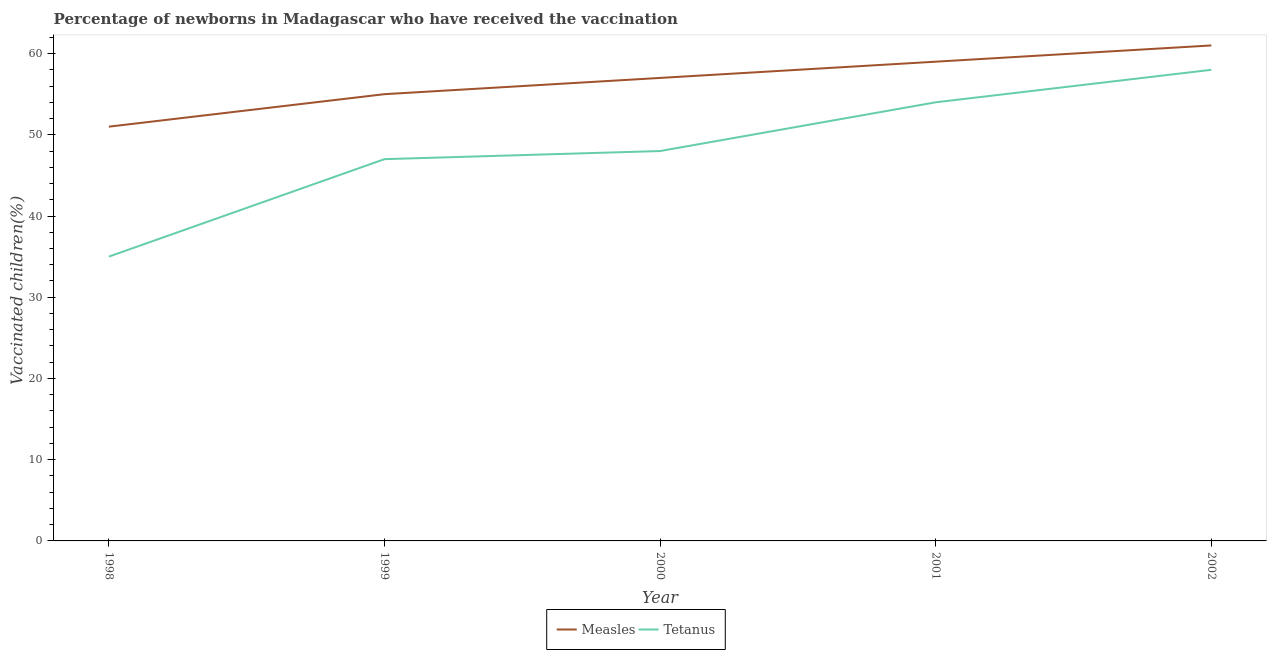Is the number of lines equal to the number of legend labels?
Your answer should be very brief. Yes. What is the percentage of newborns who received vaccination for tetanus in 2001?
Make the answer very short. 54. Across all years, what is the maximum percentage of newborns who received vaccination for tetanus?
Give a very brief answer. 58. Across all years, what is the minimum percentage of newborns who received vaccination for tetanus?
Provide a short and direct response. 35. In which year was the percentage of newborns who received vaccination for measles maximum?
Your response must be concise. 2002. What is the total percentage of newborns who received vaccination for measles in the graph?
Provide a short and direct response. 283. What is the difference between the percentage of newborns who received vaccination for tetanus in 1999 and that in 2000?
Keep it short and to the point. -1. What is the difference between the percentage of newborns who received vaccination for measles in 2001 and the percentage of newborns who received vaccination for tetanus in 1999?
Your response must be concise. 12. What is the average percentage of newborns who received vaccination for tetanus per year?
Provide a short and direct response. 48.4. In the year 2000, what is the difference between the percentage of newborns who received vaccination for tetanus and percentage of newborns who received vaccination for measles?
Give a very brief answer. -9. What is the ratio of the percentage of newborns who received vaccination for tetanus in 1999 to that in 2000?
Your answer should be very brief. 0.98. Is the percentage of newborns who received vaccination for tetanus in 1999 less than that in 2001?
Your answer should be very brief. Yes. Is the difference between the percentage of newborns who received vaccination for measles in 1999 and 2001 greater than the difference between the percentage of newborns who received vaccination for tetanus in 1999 and 2001?
Provide a short and direct response. Yes. What is the difference between the highest and the second highest percentage of newborns who received vaccination for measles?
Your response must be concise. 2. What is the difference between the highest and the lowest percentage of newborns who received vaccination for measles?
Keep it short and to the point. 10. In how many years, is the percentage of newborns who received vaccination for measles greater than the average percentage of newborns who received vaccination for measles taken over all years?
Provide a short and direct response. 3. Does the percentage of newborns who received vaccination for tetanus monotonically increase over the years?
Give a very brief answer. Yes. Is the percentage of newborns who received vaccination for measles strictly greater than the percentage of newborns who received vaccination for tetanus over the years?
Your answer should be very brief. Yes. What is the difference between two consecutive major ticks on the Y-axis?
Keep it short and to the point. 10. How many legend labels are there?
Ensure brevity in your answer.  2. How are the legend labels stacked?
Your response must be concise. Horizontal. What is the title of the graph?
Offer a very short reply. Percentage of newborns in Madagascar who have received the vaccination. What is the label or title of the Y-axis?
Give a very brief answer. Vaccinated children(%)
. What is the Vaccinated children(%)
 of Tetanus in 2000?
Your answer should be compact. 48. What is the Vaccinated children(%)
 of Tetanus in 2001?
Provide a succinct answer. 54. What is the Vaccinated children(%)
 in Measles in 2002?
Ensure brevity in your answer.  61. What is the Vaccinated children(%)
 in Tetanus in 2002?
Ensure brevity in your answer.  58. Across all years, what is the maximum Vaccinated children(%)
 of Tetanus?
Give a very brief answer. 58. Across all years, what is the minimum Vaccinated children(%)
 in Measles?
Make the answer very short. 51. Across all years, what is the minimum Vaccinated children(%)
 in Tetanus?
Ensure brevity in your answer.  35. What is the total Vaccinated children(%)
 in Measles in the graph?
Offer a terse response. 283. What is the total Vaccinated children(%)
 of Tetanus in the graph?
Give a very brief answer. 242. What is the difference between the Vaccinated children(%)
 of Measles in 1998 and that in 1999?
Your answer should be very brief. -4. What is the difference between the Vaccinated children(%)
 in Measles in 1998 and that in 2000?
Give a very brief answer. -6. What is the difference between the Vaccinated children(%)
 in Measles in 1998 and that in 2002?
Provide a short and direct response. -10. What is the difference between the Vaccinated children(%)
 in Measles in 1999 and that in 2000?
Your answer should be very brief. -2. What is the difference between the Vaccinated children(%)
 of Tetanus in 1999 and that in 2000?
Offer a very short reply. -1. What is the difference between the Vaccinated children(%)
 of Measles in 1999 and that in 2002?
Your answer should be compact. -6. What is the difference between the Vaccinated children(%)
 of Measles in 2000 and that in 2001?
Offer a terse response. -2. What is the difference between the Vaccinated children(%)
 in Measles in 2000 and that in 2002?
Give a very brief answer. -4. What is the difference between the Vaccinated children(%)
 in Measles in 1998 and the Vaccinated children(%)
 in Tetanus in 2000?
Your answer should be very brief. 3. What is the difference between the Vaccinated children(%)
 in Measles in 1998 and the Vaccinated children(%)
 in Tetanus in 2001?
Your answer should be compact. -3. What is the difference between the Vaccinated children(%)
 of Measles in 1999 and the Vaccinated children(%)
 of Tetanus in 2000?
Provide a short and direct response. 7. What is the difference between the Vaccinated children(%)
 in Measles in 1999 and the Vaccinated children(%)
 in Tetanus in 2001?
Provide a short and direct response. 1. What is the difference between the Vaccinated children(%)
 of Measles in 2000 and the Vaccinated children(%)
 of Tetanus in 2001?
Offer a very short reply. 3. What is the difference between the Vaccinated children(%)
 of Measles in 2001 and the Vaccinated children(%)
 of Tetanus in 2002?
Your answer should be very brief. 1. What is the average Vaccinated children(%)
 of Measles per year?
Your answer should be compact. 56.6. What is the average Vaccinated children(%)
 of Tetanus per year?
Keep it short and to the point. 48.4. In the year 2000, what is the difference between the Vaccinated children(%)
 in Measles and Vaccinated children(%)
 in Tetanus?
Ensure brevity in your answer.  9. In the year 2001, what is the difference between the Vaccinated children(%)
 of Measles and Vaccinated children(%)
 of Tetanus?
Give a very brief answer. 5. In the year 2002, what is the difference between the Vaccinated children(%)
 in Measles and Vaccinated children(%)
 in Tetanus?
Offer a very short reply. 3. What is the ratio of the Vaccinated children(%)
 in Measles in 1998 to that in 1999?
Your answer should be very brief. 0.93. What is the ratio of the Vaccinated children(%)
 of Tetanus in 1998 to that in 1999?
Provide a short and direct response. 0.74. What is the ratio of the Vaccinated children(%)
 in Measles in 1998 to that in 2000?
Your response must be concise. 0.89. What is the ratio of the Vaccinated children(%)
 of Tetanus in 1998 to that in 2000?
Your response must be concise. 0.73. What is the ratio of the Vaccinated children(%)
 in Measles in 1998 to that in 2001?
Ensure brevity in your answer.  0.86. What is the ratio of the Vaccinated children(%)
 in Tetanus in 1998 to that in 2001?
Your answer should be very brief. 0.65. What is the ratio of the Vaccinated children(%)
 in Measles in 1998 to that in 2002?
Make the answer very short. 0.84. What is the ratio of the Vaccinated children(%)
 in Tetanus in 1998 to that in 2002?
Your answer should be very brief. 0.6. What is the ratio of the Vaccinated children(%)
 in Measles in 1999 to that in 2000?
Offer a terse response. 0.96. What is the ratio of the Vaccinated children(%)
 of Tetanus in 1999 to that in 2000?
Give a very brief answer. 0.98. What is the ratio of the Vaccinated children(%)
 in Measles in 1999 to that in 2001?
Provide a succinct answer. 0.93. What is the ratio of the Vaccinated children(%)
 of Tetanus in 1999 to that in 2001?
Make the answer very short. 0.87. What is the ratio of the Vaccinated children(%)
 of Measles in 1999 to that in 2002?
Offer a very short reply. 0.9. What is the ratio of the Vaccinated children(%)
 of Tetanus in 1999 to that in 2002?
Provide a succinct answer. 0.81. What is the ratio of the Vaccinated children(%)
 in Measles in 2000 to that in 2001?
Provide a short and direct response. 0.97. What is the ratio of the Vaccinated children(%)
 of Tetanus in 2000 to that in 2001?
Ensure brevity in your answer.  0.89. What is the ratio of the Vaccinated children(%)
 of Measles in 2000 to that in 2002?
Provide a short and direct response. 0.93. What is the ratio of the Vaccinated children(%)
 of Tetanus in 2000 to that in 2002?
Provide a succinct answer. 0.83. What is the ratio of the Vaccinated children(%)
 of Measles in 2001 to that in 2002?
Provide a short and direct response. 0.97. What is the ratio of the Vaccinated children(%)
 of Tetanus in 2001 to that in 2002?
Provide a succinct answer. 0.93. What is the difference between the highest and the lowest Vaccinated children(%)
 in Tetanus?
Provide a succinct answer. 23. 